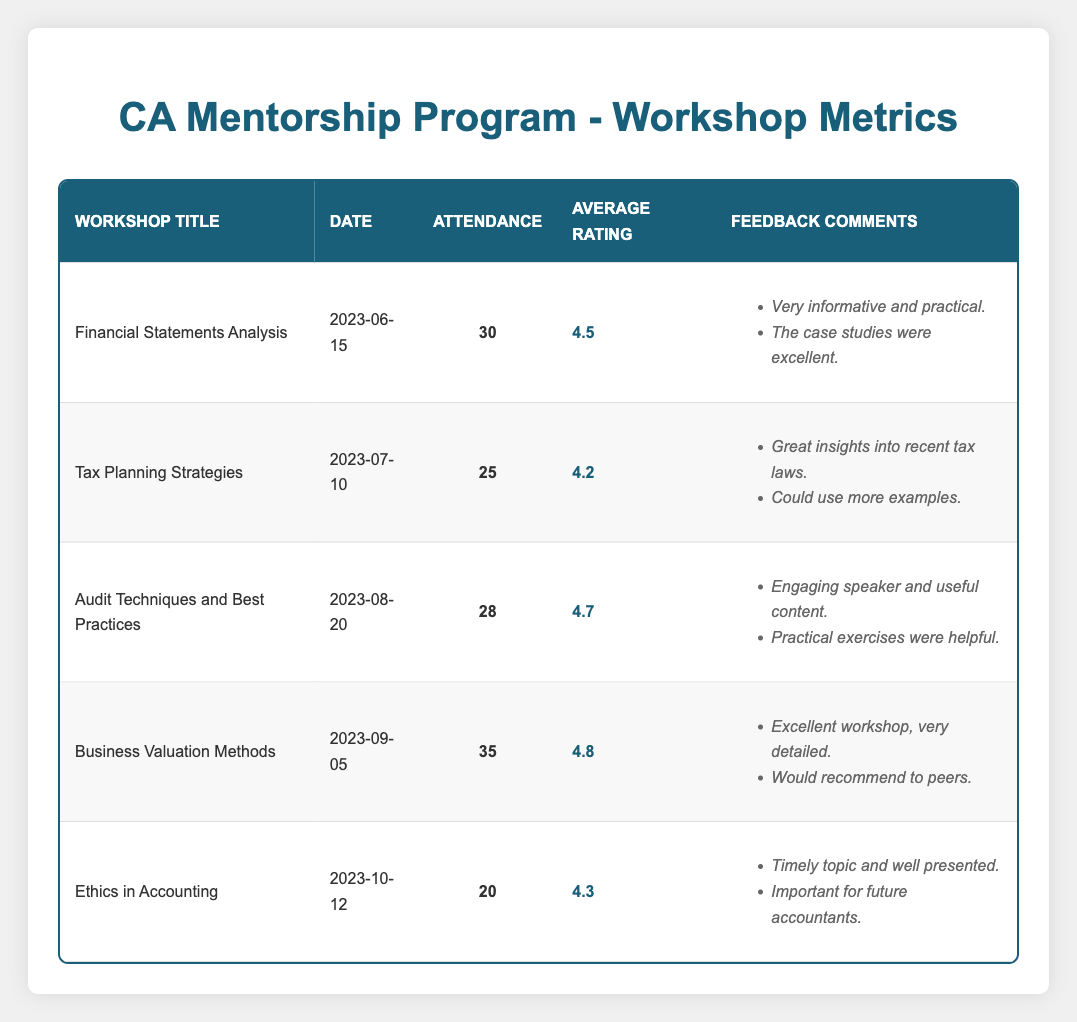What was the attendance for the "Business Valuation Methods" workshop? The table lists "Business Valuation Methods" with an attendance of 35 participants.
Answer: 35 What is the average rating of the "Audit Techniques and Best Practices" workshop? According to the table, the average rating for the "Audit Techniques and Best Practices" workshop is 4.7.
Answer: 4.7 Which workshop had the highest attendance? By comparing the attendance numbers, the "Business Valuation Methods" workshop had the highest attendance with 35 participants.
Answer: Business Valuation Methods Is there a workshop with an average rating of 4.3? Yes, the "Ethics in Accounting" workshop has an average rating of 4.3, as stated in the table.
Answer: Yes What is the total attendance across all workshops? To find the total attendance, sum the attendance values: 30 + 25 + 28 + 35 + 20 = 138. Thus, the total attendance across all workshops is 138.
Answer: 138 How many workshops have an average rating greater than 4.5? Checking the average ratings, three workshops ("Business Valuation Methods", "Audit Techniques and Best Practices", and "Financial Statements Analysis") have ratings above 4.5.
Answer: 3 What was the difference in attendance between the workshop with the highest and lowest attendance? The highest attendance was 35 (for "Business Valuation Methods") and the lowest was 20 (for "Ethics in Accounting"). The difference is calculated as 35 - 20 = 15.
Answer: 15 Did more than half of the workshops receive an average rating of 4.3 or higher? There are five workshops total, and four of them have ratings of 4.3 or higher ("Financial Statements Analysis", "Audit Techniques and Best Practices", "Business Valuation Methods", "Ethics in Accounting"). Since 4 out of 5 is more than half, the answer is yes.
Answer: Yes Which workshop had the least number of feedback comments? The "Tax Planning Strategies" workshop contains two feedback comments, which is the least compared to others which have more.
Answer: Tax Planning Strategies 